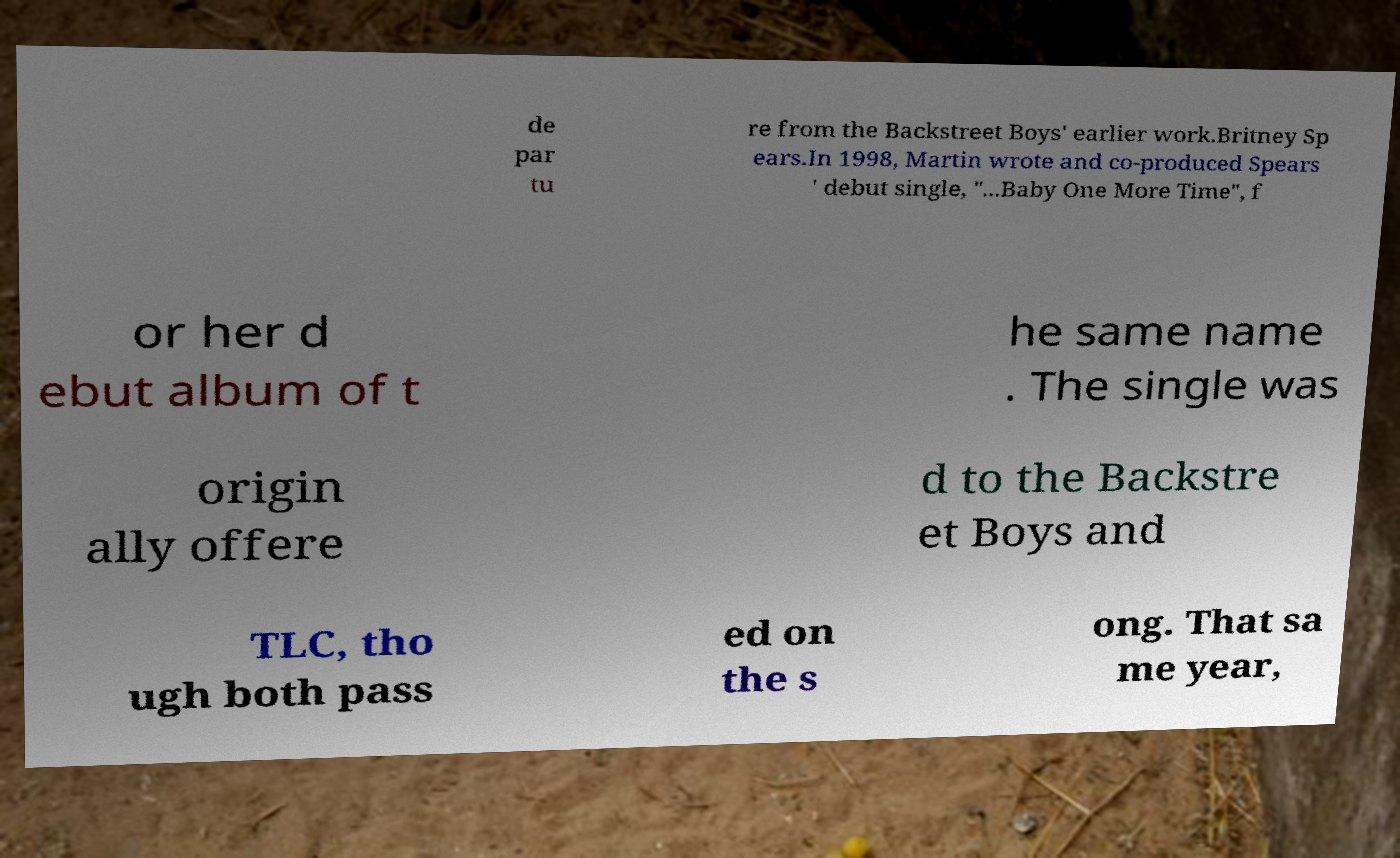For documentation purposes, I need the text within this image transcribed. Could you provide that? de par tu re from the Backstreet Boys' earlier work.Britney Sp ears.In 1998, Martin wrote and co-produced Spears ' debut single, "...Baby One More Time", f or her d ebut album of t he same name . The single was origin ally offere d to the Backstre et Boys and TLC, tho ugh both pass ed on the s ong. That sa me year, 